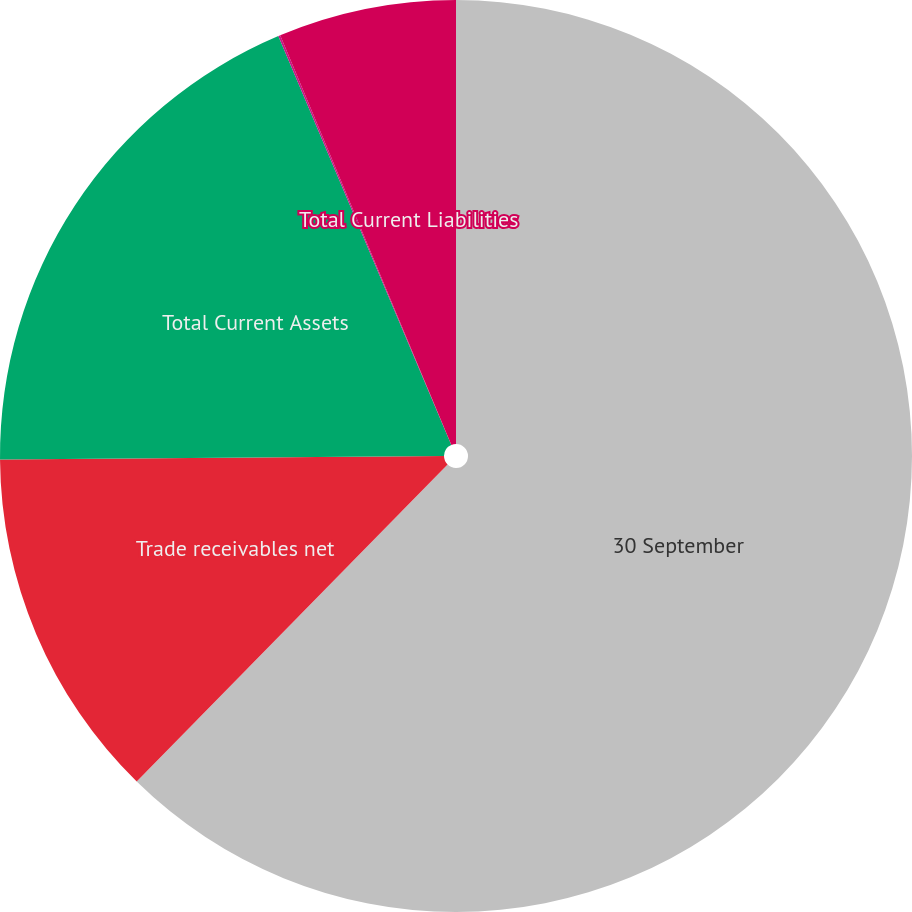<chart> <loc_0><loc_0><loc_500><loc_500><pie_chart><fcel>30 September<fcel>Trade receivables net<fcel>Total Current Assets<fcel>Payables and accrued<fcel>Total Current Liabilities<nl><fcel>62.34%<fcel>12.53%<fcel>18.75%<fcel>0.07%<fcel>6.3%<nl></chart> 